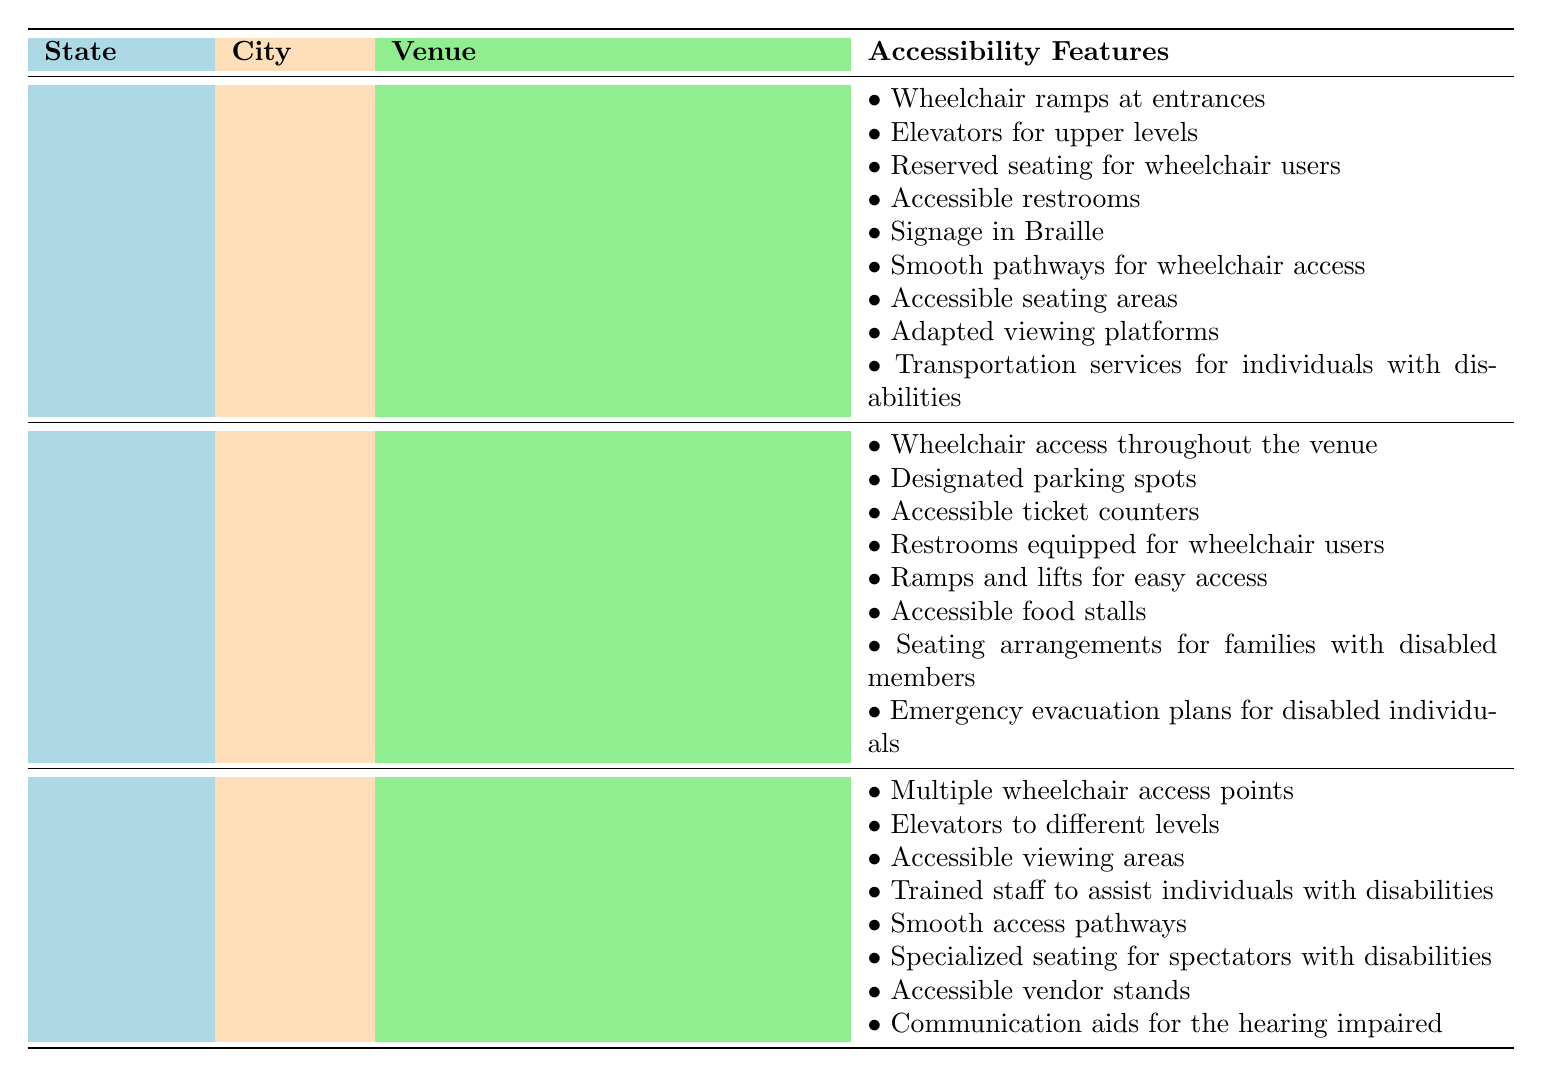Which venue in Maharashtra has reserved seating for wheelchair users? The table shows two venues in Maharashtra. Wankhede Stadium includes reserved seating for wheelchair users as one of its accessibility features, while Mahalaxmi Race Course does not mention this feature.
Answer: Wankhede Stadium Does the Indira Gandhi Arena provide ramp access? The table lists the accessibility features for the Indira Gandhi Arena, which includes ramps for easy access. Therefore, the answer is yes.
Answer: Yes How many venues in Karnataka have accessible food stalls? The table shows two venues in Karnataka: M. Chinnaswamy Stadium and Karnataka State Cricket Association. Only the Indira Gandhi Arena in Delhi has accessible food stalls. Therefore, the count in Karnataka is zero.
Answer: 0 What is the total number of unique accessibility features mentioned for venues in Mumbai? There are two venues in Mumbai: Wankhede Stadium (5 features) and Mahalaxmi Race Course (4 features). Adding these gives a total of 9 features. However, we need to check for duplicates. There are no shared features between the two venues. Thus, the total is 9 unique features.
Answer: 9 Is there a venue in New Delhi that has accessible ticket counters? According to the table, the Jawaharlal Nehru Stadium features accessible ticket counters among its accessibility features, confirming that there is a venue that provides this service.
Answer: Yes Which state has the venue with the most accessibility features? By checking the venue details, Wankhede Stadium in Maharashtra has 5 features and Jawaharlal Nehru Stadium in New Delhi has 4. M. Chinnaswamy Stadium and Karnataka State Cricket Association in Karnataka have 4 features each. Hence, Wankhede Stadium from Maharashtra has the most features at 5.
Answer: Maharashtra What does the Karnataka State Cricket Association offer for spectators with disabilities? The table indicates that the Karnataka State Cricket Association has specialized seating for spectators with disabilities among its features.
Answer: Specialized seating How many venues listed have emergency evacuation plans for disabled individuals? The table mentions that only the Indira Gandhi Arena in New Delhi has emergency evacuation plans for disabled individuals. Therefore, the count is one.
Answer: 1 Which venue has features specifically designed for the hearing impaired? The only venue that includes communication aids for the hearing impaired is the Karnataka State Cricket Association.
Answer: Karnataka State Cricket Association 